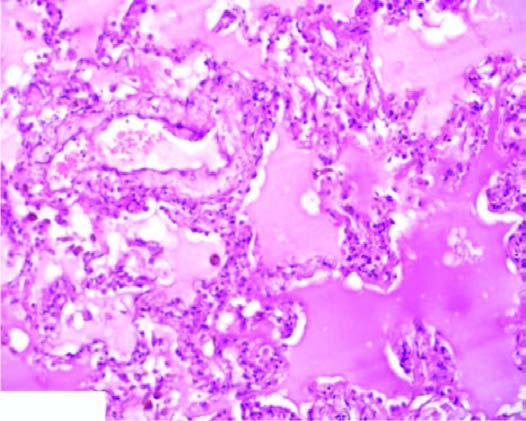what contain eosinophilic, granular, homogeneous and pink proteinaceous oedema fluid along with some rbcs and inflammatory cells?
Answer the question using a single word or phrase. The alveolar spaces 